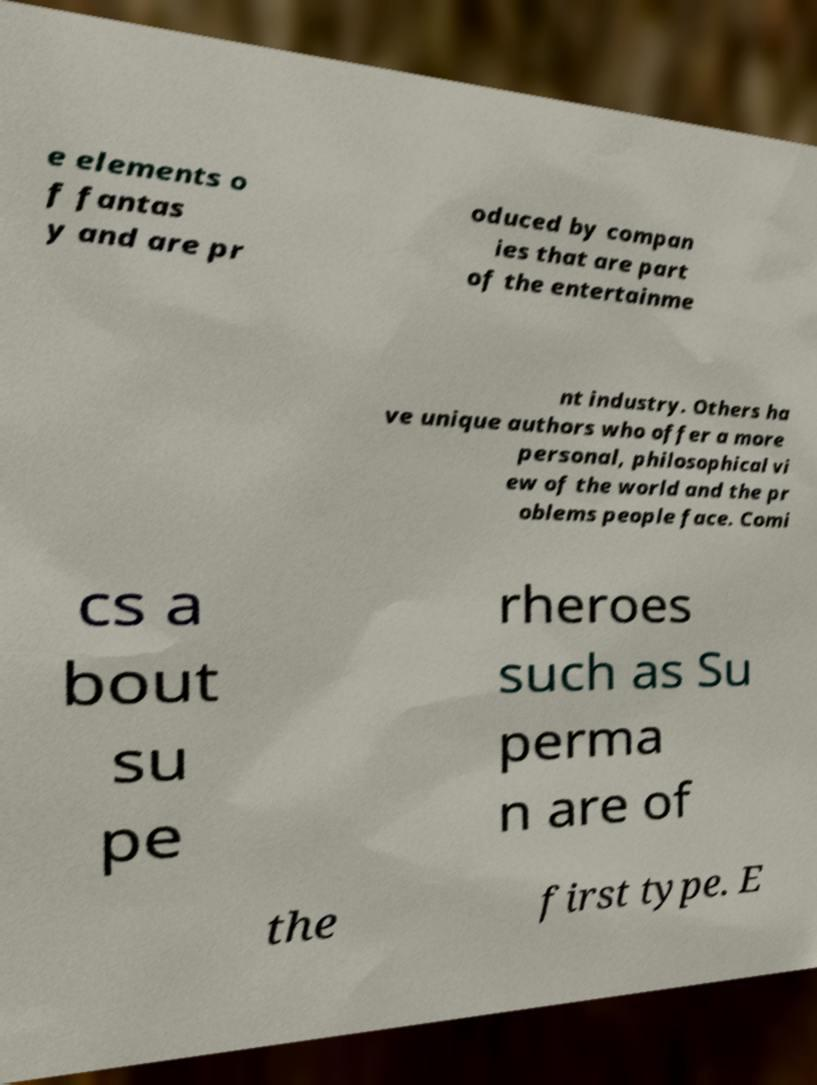Please read and relay the text visible in this image. What does it say? e elements o f fantas y and are pr oduced by compan ies that are part of the entertainme nt industry. Others ha ve unique authors who offer a more personal, philosophical vi ew of the world and the pr oblems people face. Comi cs a bout su pe rheroes such as Su perma n are of the first type. E 